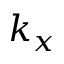Convert formula to latex. <formula><loc_0><loc_0><loc_500><loc_500>k _ { x }</formula> 